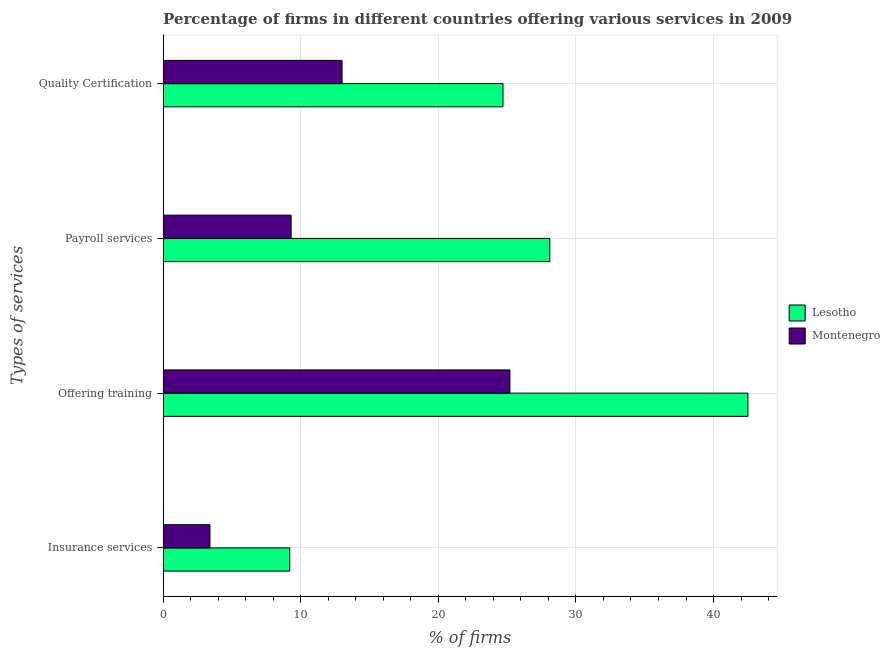How many groups of bars are there?
Your response must be concise. 4. Are the number of bars per tick equal to the number of legend labels?
Provide a succinct answer. Yes. Are the number of bars on each tick of the Y-axis equal?
Your answer should be very brief. Yes. What is the label of the 1st group of bars from the top?
Your answer should be compact. Quality Certification. What is the percentage of firms offering insurance services in Montenegro?
Your response must be concise. 3.4. Across all countries, what is the maximum percentage of firms offering quality certification?
Offer a terse response. 24.7. In which country was the percentage of firms offering insurance services maximum?
Your response must be concise. Lesotho. In which country was the percentage of firms offering insurance services minimum?
Your answer should be very brief. Montenegro. What is the total percentage of firms offering insurance services in the graph?
Ensure brevity in your answer.  12.6. What is the difference between the percentage of firms offering payroll services in Montenegro and the percentage of firms offering training in Lesotho?
Your answer should be compact. -33.2. What is the average percentage of firms offering insurance services per country?
Keep it short and to the point. 6.3. What is the difference between the percentage of firms offering quality certification and percentage of firms offering payroll services in Lesotho?
Give a very brief answer. -3.4. What is the ratio of the percentage of firms offering training in Montenegro to that in Lesotho?
Your response must be concise. 0.59. Is the percentage of firms offering quality certification in Lesotho less than that in Montenegro?
Keep it short and to the point. No. Is the difference between the percentage of firms offering insurance services in Montenegro and Lesotho greater than the difference between the percentage of firms offering training in Montenegro and Lesotho?
Provide a succinct answer. Yes. In how many countries, is the percentage of firms offering payroll services greater than the average percentage of firms offering payroll services taken over all countries?
Keep it short and to the point. 1. Is the sum of the percentage of firms offering insurance services in Lesotho and Montenegro greater than the maximum percentage of firms offering quality certification across all countries?
Provide a succinct answer. No. Is it the case that in every country, the sum of the percentage of firms offering insurance services and percentage of firms offering quality certification is greater than the sum of percentage of firms offering training and percentage of firms offering payroll services?
Ensure brevity in your answer.  No. What does the 2nd bar from the top in Quality Certification represents?
Offer a terse response. Lesotho. What does the 2nd bar from the bottom in Insurance services represents?
Give a very brief answer. Montenegro. Are all the bars in the graph horizontal?
Your response must be concise. Yes. How many countries are there in the graph?
Your answer should be compact. 2. Does the graph contain any zero values?
Make the answer very short. No. How many legend labels are there?
Offer a terse response. 2. What is the title of the graph?
Your answer should be very brief. Percentage of firms in different countries offering various services in 2009. What is the label or title of the X-axis?
Keep it short and to the point. % of firms. What is the label or title of the Y-axis?
Your answer should be very brief. Types of services. What is the % of firms in Lesotho in Insurance services?
Offer a very short reply. 9.2. What is the % of firms in Montenegro in Insurance services?
Ensure brevity in your answer.  3.4. What is the % of firms in Lesotho in Offering training?
Your answer should be very brief. 42.5. What is the % of firms of Montenegro in Offering training?
Provide a short and direct response. 25.2. What is the % of firms in Lesotho in Payroll services?
Your answer should be very brief. 28.1. What is the % of firms of Lesotho in Quality Certification?
Your answer should be very brief. 24.7. What is the % of firms of Montenegro in Quality Certification?
Ensure brevity in your answer.  13. Across all Types of services, what is the maximum % of firms of Lesotho?
Give a very brief answer. 42.5. Across all Types of services, what is the maximum % of firms in Montenegro?
Provide a succinct answer. 25.2. What is the total % of firms of Lesotho in the graph?
Your answer should be compact. 104.5. What is the total % of firms of Montenegro in the graph?
Offer a terse response. 50.9. What is the difference between the % of firms in Lesotho in Insurance services and that in Offering training?
Ensure brevity in your answer.  -33.3. What is the difference between the % of firms of Montenegro in Insurance services and that in Offering training?
Make the answer very short. -21.8. What is the difference between the % of firms in Lesotho in Insurance services and that in Payroll services?
Keep it short and to the point. -18.9. What is the difference between the % of firms in Montenegro in Insurance services and that in Payroll services?
Provide a succinct answer. -5.9. What is the difference between the % of firms of Lesotho in Insurance services and that in Quality Certification?
Ensure brevity in your answer.  -15.5. What is the difference between the % of firms in Montenegro in Insurance services and that in Quality Certification?
Your response must be concise. -9.6. What is the difference between the % of firms in Lesotho in Offering training and that in Payroll services?
Your answer should be compact. 14.4. What is the difference between the % of firms of Lesotho in Offering training and that in Quality Certification?
Give a very brief answer. 17.8. What is the difference between the % of firms in Lesotho in Payroll services and that in Quality Certification?
Provide a short and direct response. 3.4. What is the difference between the % of firms of Montenegro in Payroll services and that in Quality Certification?
Keep it short and to the point. -3.7. What is the difference between the % of firms of Lesotho in Insurance services and the % of firms of Montenegro in Offering training?
Offer a terse response. -16. What is the difference between the % of firms of Lesotho in Offering training and the % of firms of Montenegro in Payroll services?
Provide a short and direct response. 33.2. What is the difference between the % of firms of Lesotho in Offering training and the % of firms of Montenegro in Quality Certification?
Offer a terse response. 29.5. What is the average % of firms in Lesotho per Types of services?
Provide a succinct answer. 26.12. What is the average % of firms in Montenegro per Types of services?
Provide a short and direct response. 12.72. What is the difference between the % of firms of Lesotho and % of firms of Montenegro in Payroll services?
Your answer should be very brief. 18.8. What is the difference between the % of firms of Lesotho and % of firms of Montenegro in Quality Certification?
Provide a short and direct response. 11.7. What is the ratio of the % of firms in Lesotho in Insurance services to that in Offering training?
Your response must be concise. 0.22. What is the ratio of the % of firms in Montenegro in Insurance services to that in Offering training?
Provide a short and direct response. 0.13. What is the ratio of the % of firms of Lesotho in Insurance services to that in Payroll services?
Your response must be concise. 0.33. What is the ratio of the % of firms of Montenegro in Insurance services to that in Payroll services?
Keep it short and to the point. 0.37. What is the ratio of the % of firms of Lesotho in Insurance services to that in Quality Certification?
Provide a short and direct response. 0.37. What is the ratio of the % of firms in Montenegro in Insurance services to that in Quality Certification?
Keep it short and to the point. 0.26. What is the ratio of the % of firms of Lesotho in Offering training to that in Payroll services?
Offer a very short reply. 1.51. What is the ratio of the % of firms in Montenegro in Offering training to that in Payroll services?
Your answer should be very brief. 2.71. What is the ratio of the % of firms in Lesotho in Offering training to that in Quality Certification?
Ensure brevity in your answer.  1.72. What is the ratio of the % of firms of Montenegro in Offering training to that in Quality Certification?
Provide a succinct answer. 1.94. What is the ratio of the % of firms in Lesotho in Payroll services to that in Quality Certification?
Ensure brevity in your answer.  1.14. What is the ratio of the % of firms of Montenegro in Payroll services to that in Quality Certification?
Give a very brief answer. 0.72. What is the difference between the highest and the lowest % of firms of Lesotho?
Your response must be concise. 33.3. What is the difference between the highest and the lowest % of firms in Montenegro?
Provide a short and direct response. 21.8. 